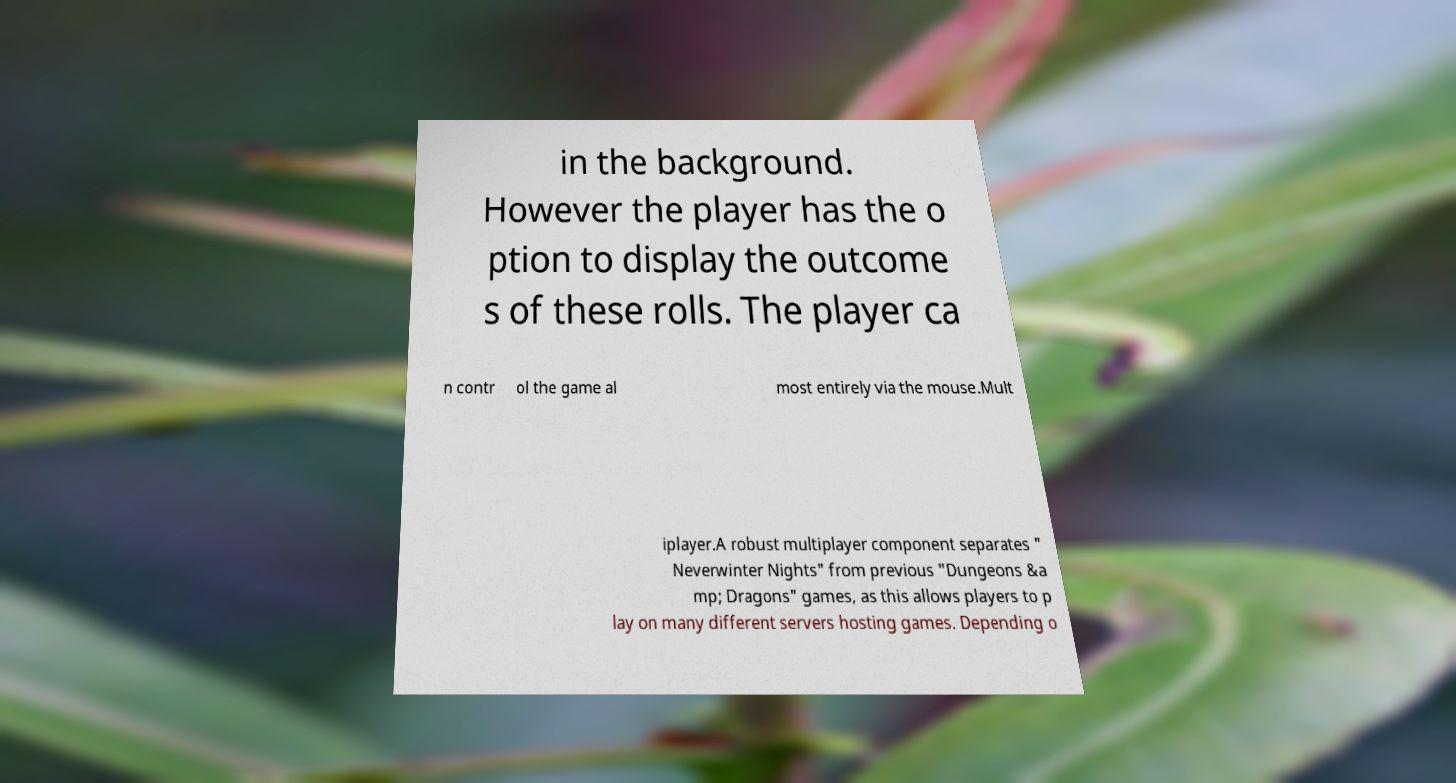There's text embedded in this image that I need extracted. Can you transcribe it verbatim? in the background. However the player has the o ption to display the outcome s of these rolls. The player ca n contr ol the game al most entirely via the mouse.Mult iplayer.A robust multiplayer component separates " Neverwinter Nights" from previous "Dungeons &a mp; Dragons" games, as this allows players to p lay on many different servers hosting games. Depending o 